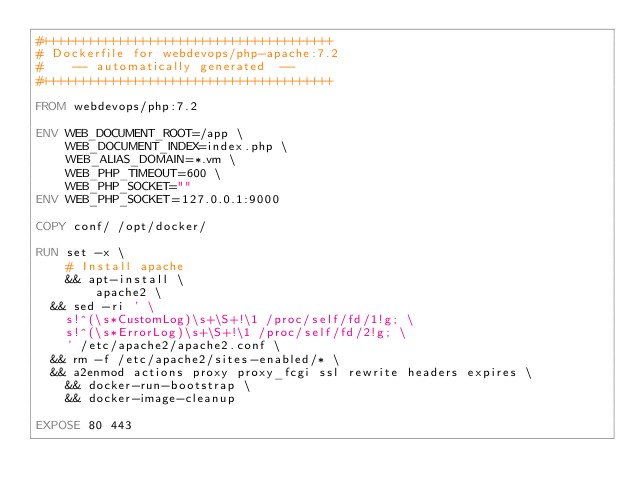Convert code to text. <code><loc_0><loc_0><loc_500><loc_500><_Dockerfile_>#+++++++++++++++++++++++++++++++++++++++
# Dockerfile for webdevops/php-apache:7.2
#    -- automatically generated  --
#+++++++++++++++++++++++++++++++++++++++

FROM webdevops/php:7.2

ENV WEB_DOCUMENT_ROOT=/app \
    WEB_DOCUMENT_INDEX=index.php \
    WEB_ALIAS_DOMAIN=*.vm \
    WEB_PHP_TIMEOUT=600 \
    WEB_PHP_SOCKET=""
ENV WEB_PHP_SOCKET=127.0.0.1:9000

COPY conf/ /opt/docker/

RUN set -x \
    # Install apache
    && apt-install \
        apache2 \
	&& sed -ri ' \
		s!^(\s*CustomLog)\s+\S+!\1 /proc/self/fd/1!g; \
		s!^(\s*ErrorLog)\s+\S+!\1 /proc/self/fd/2!g; \
		' /etc/apache2/apache2.conf \
	&& rm -f /etc/apache2/sites-enabled/* \
	&& a2enmod actions proxy proxy_fcgi ssl rewrite headers expires \
    && docker-run-bootstrap \
    && docker-image-cleanup

EXPOSE 80 443
</code> 